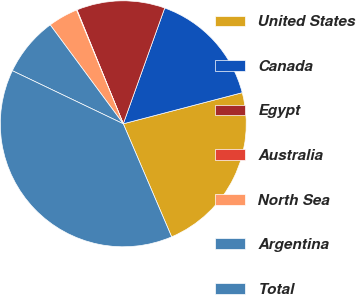Convert chart to OTSL. <chart><loc_0><loc_0><loc_500><loc_500><pie_chart><fcel>United States<fcel>Canada<fcel>Egypt<fcel>Australia<fcel>North Sea<fcel>Argentina<fcel>Total<nl><fcel>22.64%<fcel>15.46%<fcel>11.61%<fcel>0.07%<fcel>3.92%<fcel>7.77%<fcel>38.54%<nl></chart> 